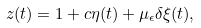<formula> <loc_0><loc_0><loc_500><loc_500>z ( t ) = 1 + c \eta ( t ) + \mu _ { \epsilon } \delta \xi ( t ) ,</formula> 